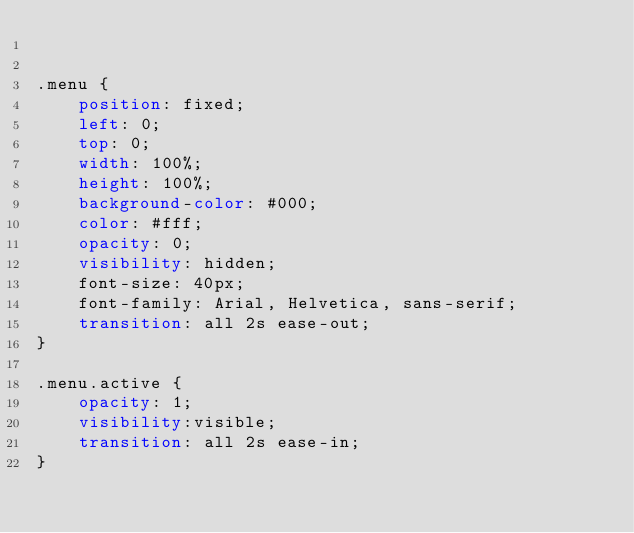<code> <loc_0><loc_0><loc_500><loc_500><_CSS_>

.menu {
    position: fixed;
    left: 0;
    top: 0;
    width: 100%;
    height: 100%;
    background-color: #000;
    color: #fff;
    opacity: 0;
    visibility: hidden;
    font-size: 40px;
    font-family: Arial, Helvetica, sans-serif;
    transition: all 2s ease-out;
}

.menu.active {
    opacity: 1;
    visibility:visible;
    transition: all 2s ease-in;
}</code> 